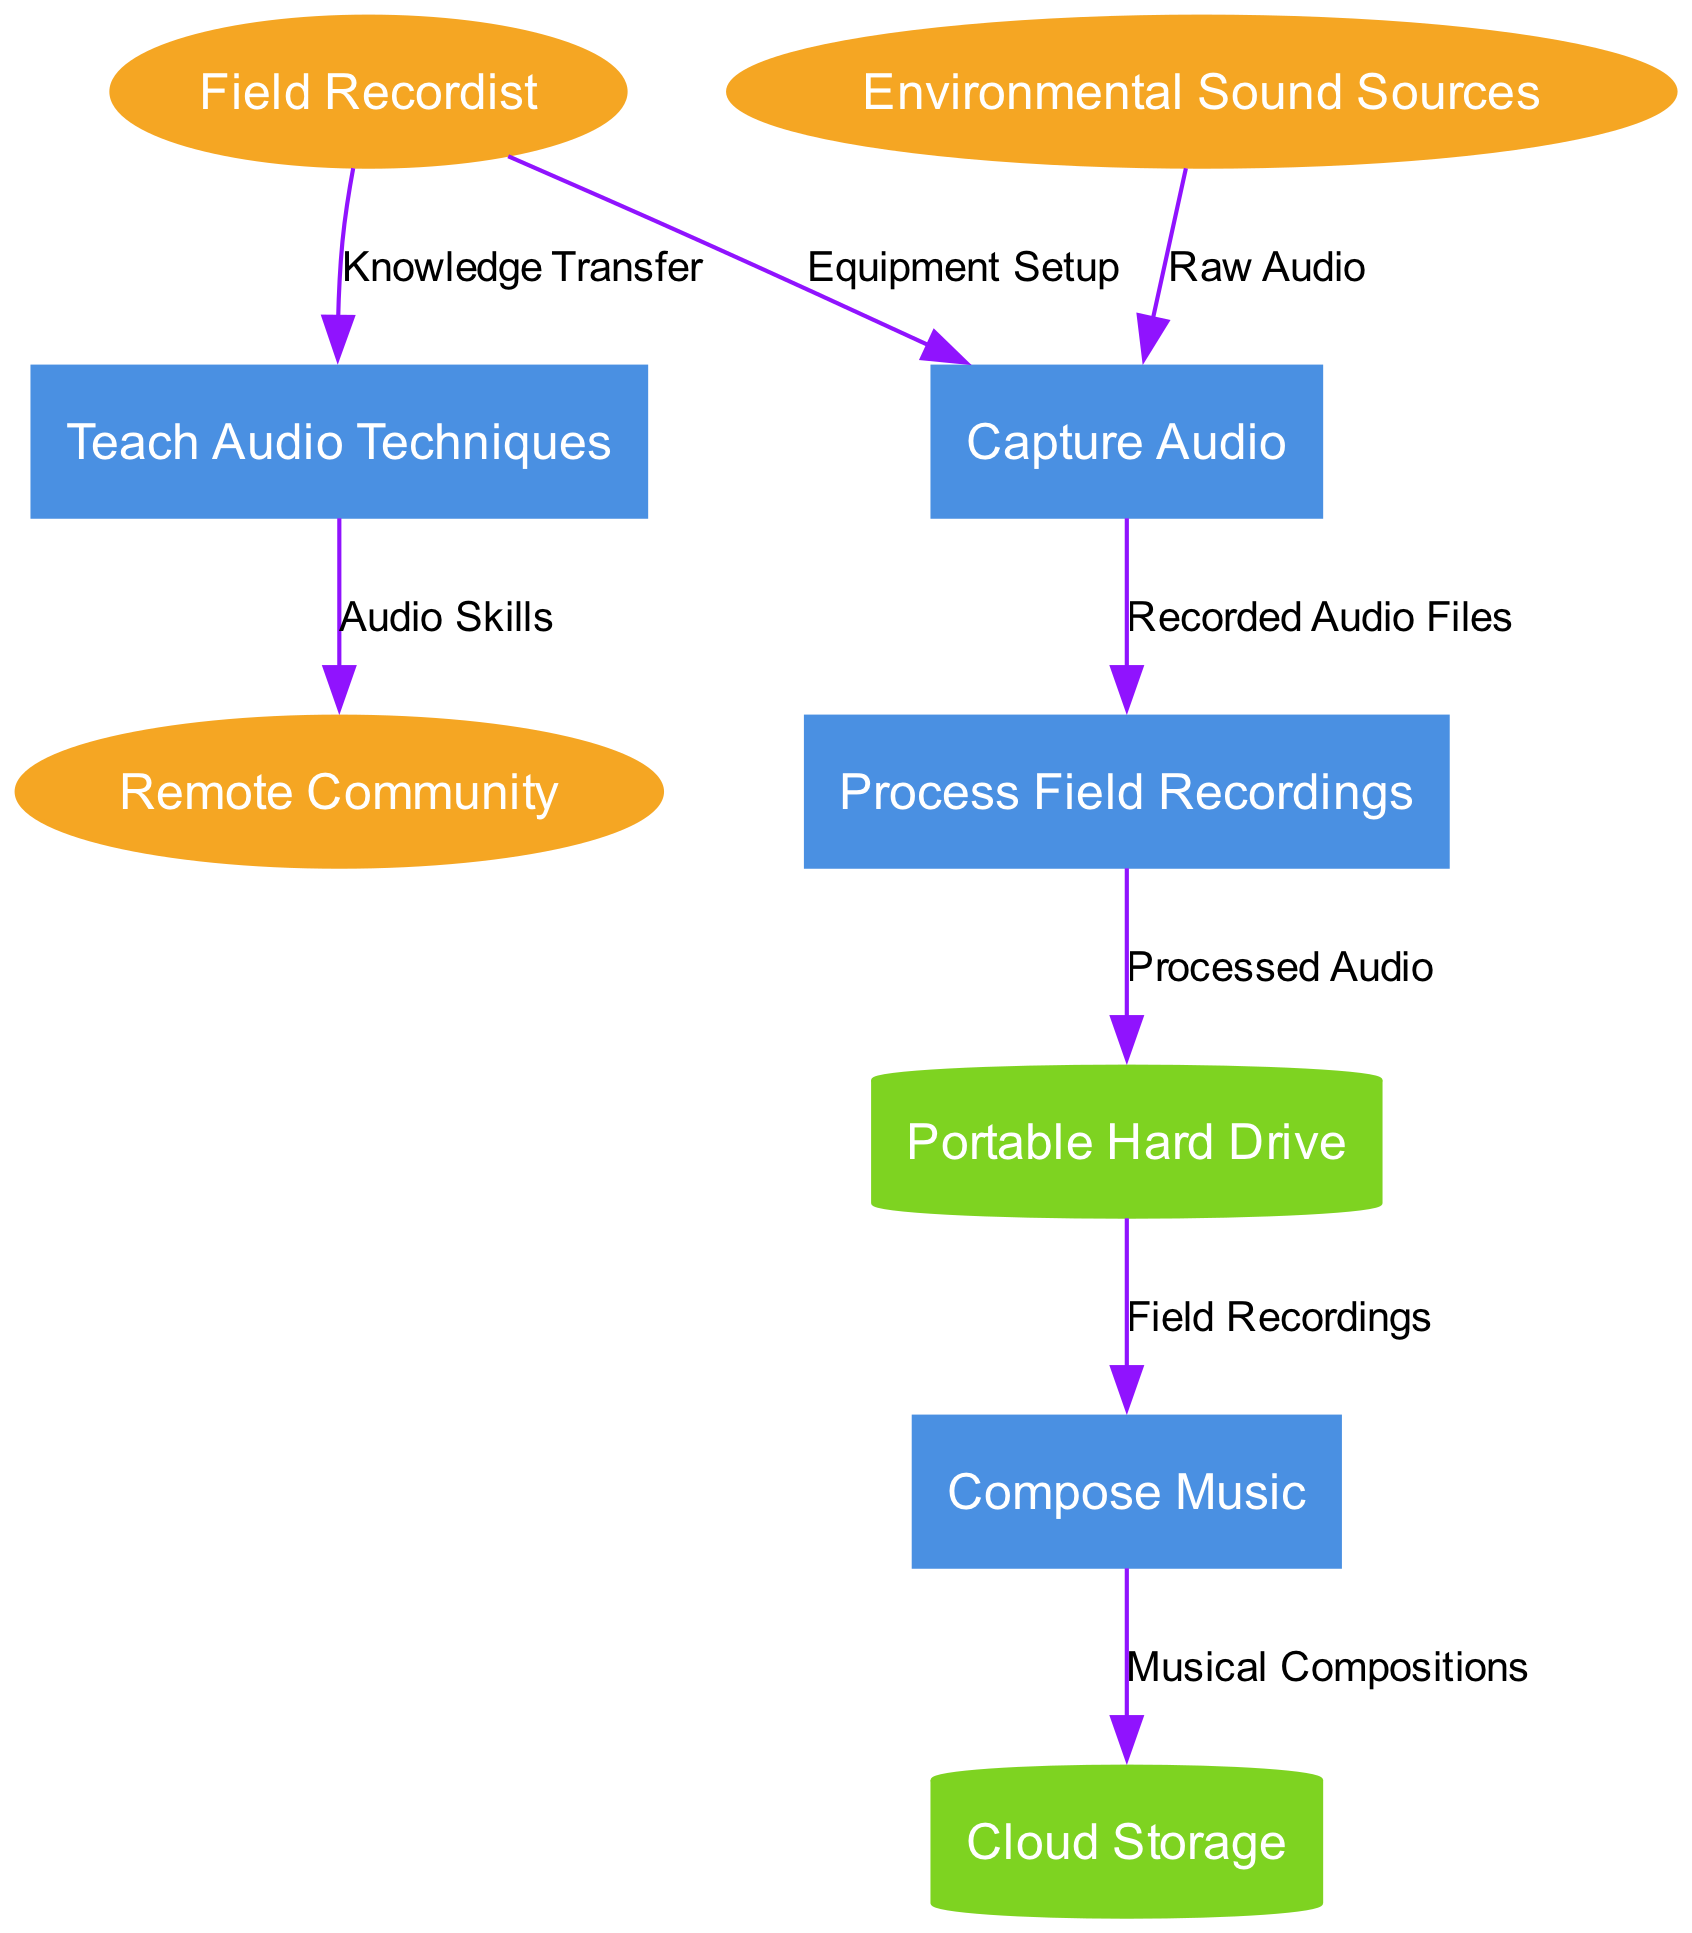What are the external entities in the diagram? The external entities are represented as ellipses in the diagram. They are listed at the top and include: Field Recordist, Remote Community, and Environmental Sound Sources.
Answer: Field Recordist, Remote Community, Environmental Sound Sources What is the first process in the signal flow? The processes are represented as rectangles in the diagram, flowing from left to right. The first process that receives input from external entities is "Capture Audio."
Answer: Capture Audio How many data stores are present in the diagram? Data stores are represented as cylinders in the diagram, and when counting, we find that there are two: Portable Hard Drive and Cloud Storage.
Answer: 2 What type of data flow comes from the "Capture Audio" process to the "Process Field Recordings" process? The data flow from "Capture Audio" to "Process Field Recordings" is labeled "Recorded Audio Files." This indicates the type of data being transferred between these two processes.
Answer: Recorded Audio Files What is the relationship between "Field Recordist" and "Teach Audio Techniques"? The relationship is established through a direct data flow labeled “Knowledge Transfer,” indicating that the Field Recordist shares knowledge about audio techniques.
Answer: Knowledge Transfer What happens to the "Processed Audio" after it is generated? After "Processed Audio" is created in the "Process Field Recordings" process, it is stored in the "Portable Hard Drive." This shows the flow of processed data storage.
Answer: Portable Hard Drive How is the data flow from "Compose Music" to "Cloud Storage" characterized? This data flow is characterized as "Musical Compositions," illustrating that the result of composing music is stored in the cloud for later access.
Answer: Musical Compositions Which process involves interaction with the Remote Community? The interaction with the Remote Community occurs during the "Teach Audio Techniques" process. This shows that audio skills are transferred to the community through this process.
Answer: Teach Audio Techniques What is the last process in the workflow according to the diagram? The last process in the workflow is "Compose Music." It comes after all the audio has been captured and processed, culminating in the composition of music.
Answer: Compose Music 